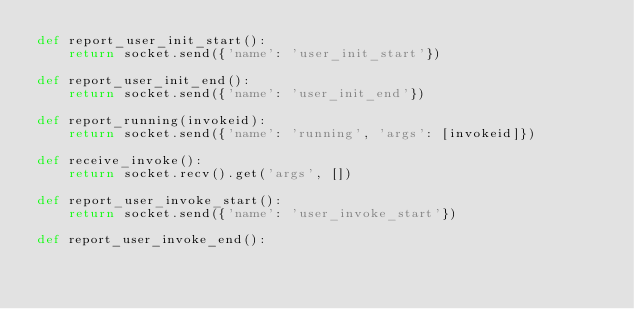Convert code to text. <code><loc_0><loc_0><loc_500><loc_500><_Python_>def report_user_init_start():
    return socket.send({'name': 'user_init_start'})

def report_user_init_end():
    return socket.send({'name': 'user_init_end'})

def report_running(invokeid):
    return socket.send({'name': 'running', 'args': [invokeid]})

def receive_invoke():
    return socket.recv().get('args', [])

def report_user_invoke_start():
    return socket.send({'name': 'user_invoke_start'})

def report_user_invoke_end():</code> 